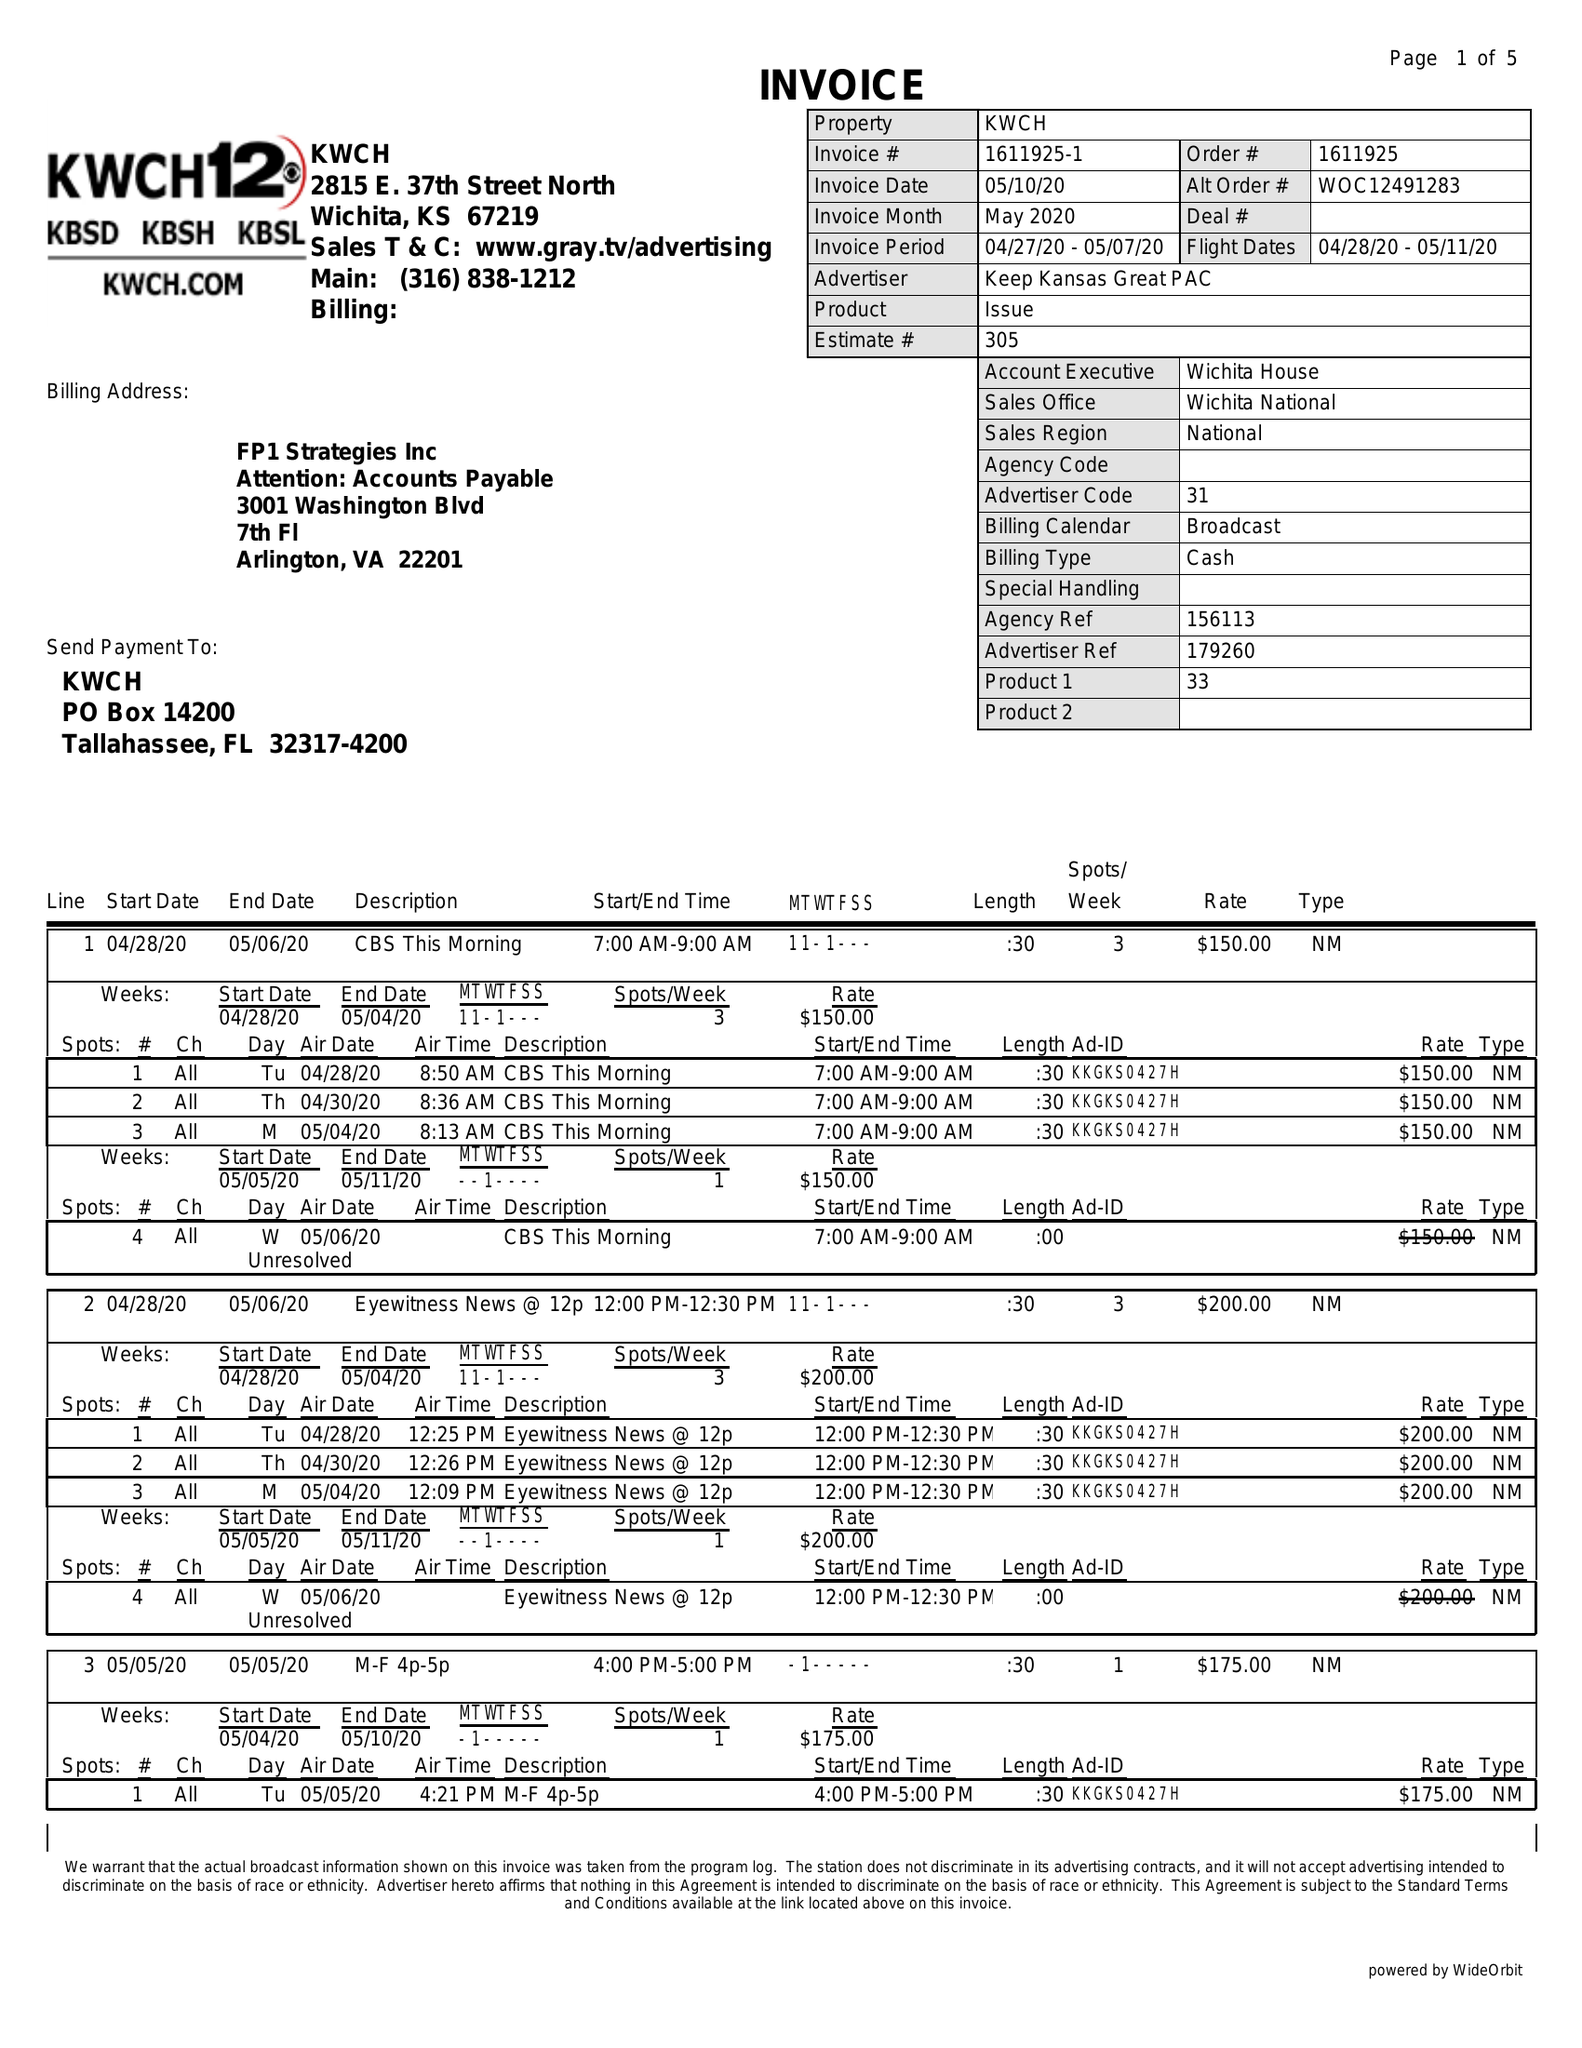What is the value for the contract_num?
Answer the question using a single word or phrase. 1611925 